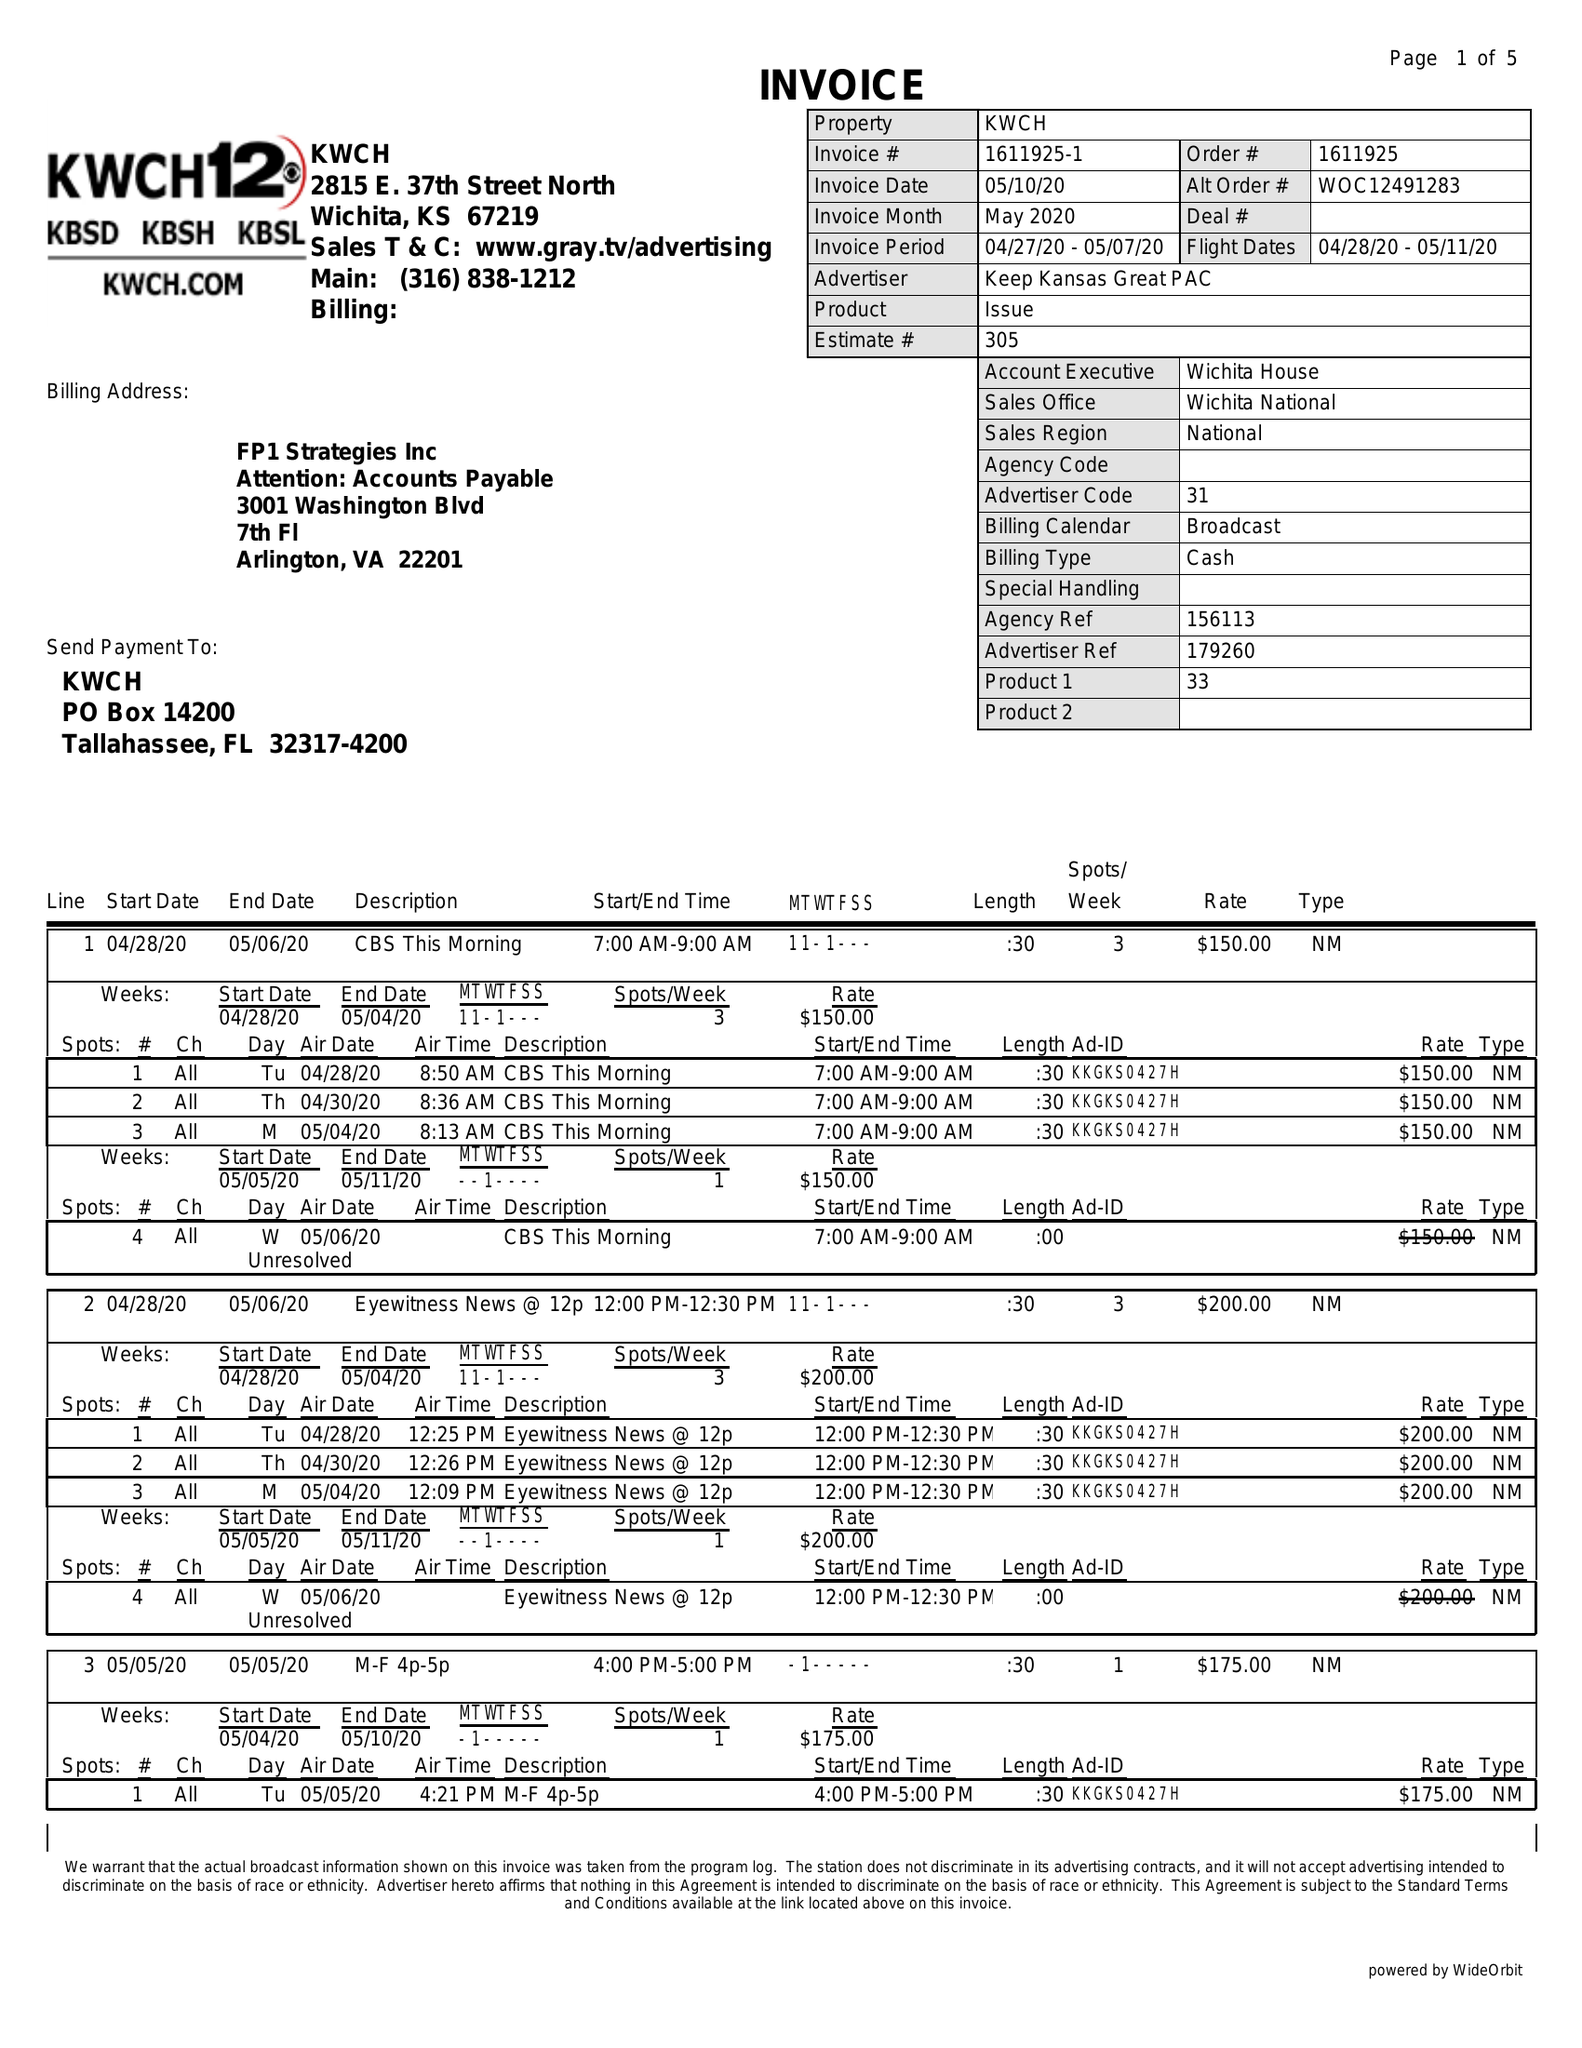What is the value for the contract_num?
Answer the question using a single word or phrase. 1611925 